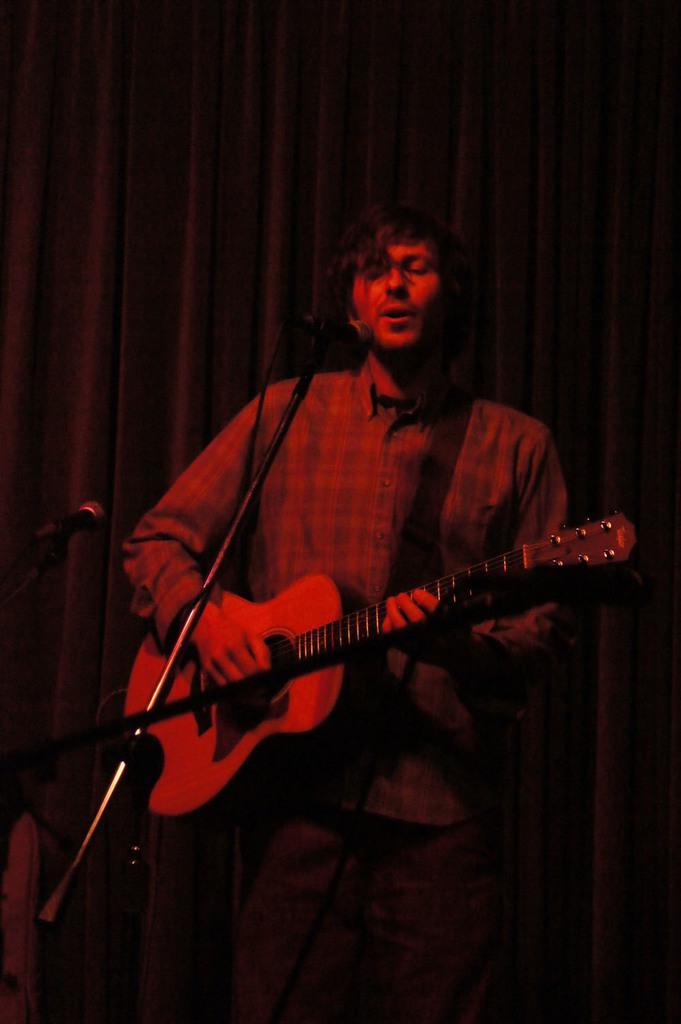Please provide a concise description of this image. In this picture we can see man holding guitar in his hand and playing it and singing on mic and in the background we can see curtain. 